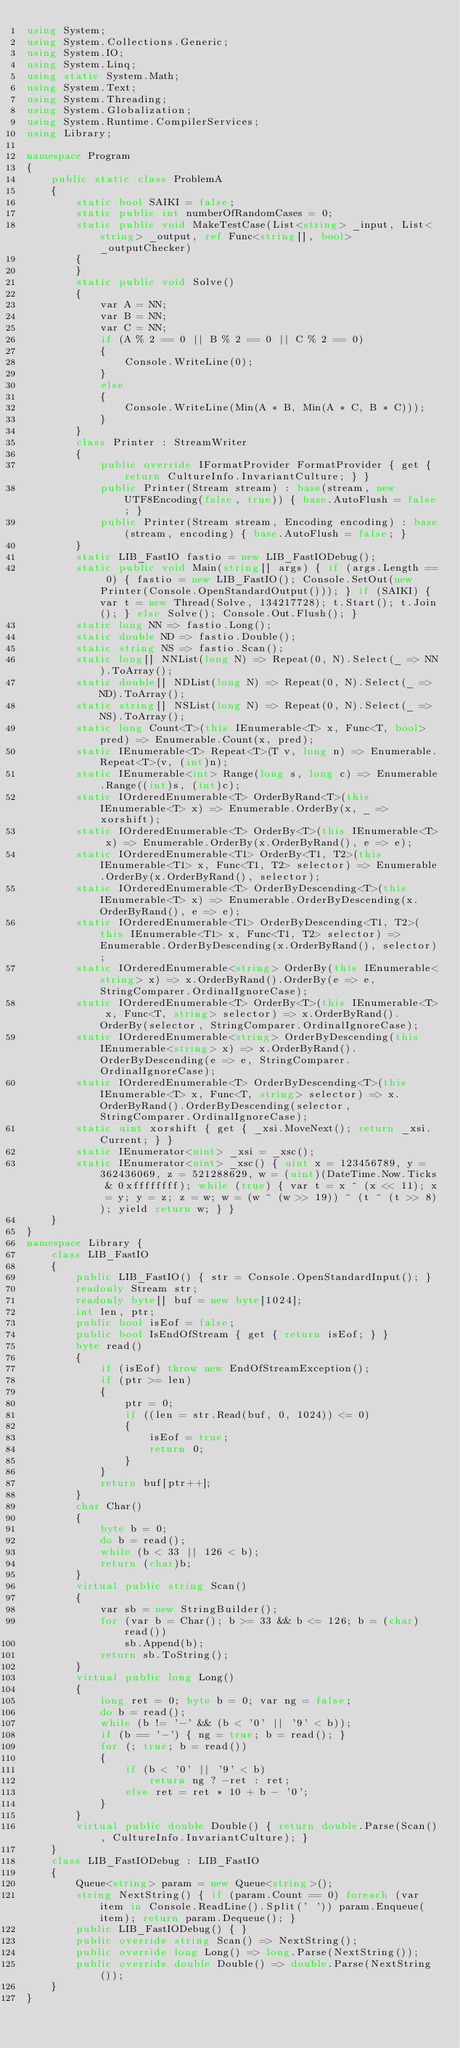<code> <loc_0><loc_0><loc_500><loc_500><_C#_>using System;
using System.Collections.Generic;
using System.IO;
using System.Linq;
using static System.Math;
using System.Text;
using System.Threading;
using System.Globalization;
using System.Runtime.CompilerServices;
using Library;

namespace Program
{
    public static class ProblemA
    {
        static bool SAIKI = false;
        static public int numberOfRandomCases = 0;
        static public void MakeTestCase(List<string> _input, List<string> _output, ref Func<string[], bool> _outputChecker)
        {
        }
        static public void Solve()
        {
            var A = NN;
            var B = NN;
            var C = NN;
            if (A % 2 == 0 || B % 2 == 0 || C % 2 == 0)
            {
                Console.WriteLine(0);
            }
            else
            {
                Console.WriteLine(Min(A * B, Min(A * C, B * C)));
            }
        }
        class Printer : StreamWriter
        {
            public override IFormatProvider FormatProvider { get { return CultureInfo.InvariantCulture; } }
            public Printer(Stream stream) : base(stream, new UTF8Encoding(false, true)) { base.AutoFlush = false; }
            public Printer(Stream stream, Encoding encoding) : base(stream, encoding) { base.AutoFlush = false; }
        }
        static LIB_FastIO fastio = new LIB_FastIODebug();
        static public void Main(string[] args) { if (args.Length == 0) { fastio = new LIB_FastIO(); Console.SetOut(new Printer(Console.OpenStandardOutput())); } if (SAIKI) { var t = new Thread(Solve, 134217728); t.Start(); t.Join(); } else Solve(); Console.Out.Flush(); }
        static long NN => fastio.Long();
        static double ND => fastio.Double();
        static string NS => fastio.Scan();
        static long[] NNList(long N) => Repeat(0, N).Select(_ => NN).ToArray();
        static double[] NDList(long N) => Repeat(0, N).Select(_ => ND).ToArray();
        static string[] NSList(long N) => Repeat(0, N).Select(_ => NS).ToArray();
        static long Count<T>(this IEnumerable<T> x, Func<T, bool> pred) => Enumerable.Count(x, pred);
        static IEnumerable<T> Repeat<T>(T v, long n) => Enumerable.Repeat<T>(v, (int)n);
        static IEnumerable<int> Range(long s, long c) => Enumerable.Range((int)s, (int)c);
        static IOrderedEnumerable<T> OrderByRand<T>(this IEnumerable<T> x) => Enumerable.OrderBy(x, _ => xorshift);
        static IOrderedEnumerable<T> OrderBy<T>(this IEnumerable<T> x) => Enumerable.OrderBy(x.OrderByRand(), e => e);
        static IOrderedEnumerable<T1> OrderBy<T1, T2>(this IEnumerable<T1> x, Func<T1, T2> selector) => Enumerable.OrderBy(x.OrderByRand(), selector);
        static IOrderedEnumerable<T> OrderByDescending<T>(this IEnumerable<T> x) => Enumerable.OrderByDescending(x.OrderByRand(), e => e);
        static IOrderedEnumerable<T1> OrderByDescending<T1, T2>(this IEnumerable<T1> x, Func<T1, T2> selector) => Enumerable.OrderByDescending(x.OrderByRand(), selector);
        static IOrderedEnumerable<string> OrderBy(this IEnumerable<string> x) => x.OrderByRand().OrderBy(e => e, StringComparer.OrdinalIgnoreCase);
        static IOrderedEnumerable<T> OrderBy<T>(this IEnumerable<T> x, Func<T, string> selector) => x.OrderByRand().OrderBy(selector, StringComparer.OrdinalIgnoreCase);
        static IOrderedEnumerable<string> OrderByDescending(this IEnumerable<string> x) => x.OrderByRand().OrderByDescending(e => e, StringComparer.OrdinalIgnoreCase);
        static IOrderedEnumerable<T> OrderByDescending<T>(this IEnumerable<T> x, Func<T, string> selector) => x.OrderByRand().OrderByDescending(selector, StringComparer.OrdinalIgnoreCase);
        static uint xorshift { get { _xsi.MoveNext(); return _xsi.Current; } }
        static IEnumerator<uint> _xsi = _xsc();
        static IEnumerator<uint> _xsc() { uint x = 123456789, y = 362436069, z = 521288629, w = (uint)(DateTime.Now.Ticks & 0xffffffff); while (true) { var t = x ^ (x << 11); x = y; y = z; z = w; w = (w ^ (w >> 19)) ^ (t ^ (t >> 8)); yield return w; } }
    }
}
namespace Library {
    class LIB_FastIO
    {
        public LIB_FastIO() { str = Console.OpenStandardInput(); }
        readonly Stream str;
        readonly byte[] buf = new byte[1024];
        int len, ptr;
        public bool isEof = false;
        public bool IsEndOfStream { get { return isEof; } }
        byte read()
        {
            if (isEof) throw new EndOfStreamException();
            if (ptr >= len)
            {
                ptr = 0;
                if ((len = str.Read(buf, 0, 1024)) <= 0)
                {
                    isEof = true;
                    return 0;
                }
            }
            return buf[ptr++];
        }
        char Char()
        {
            byte b = 0;
            do b = read();
            while (b < 33 || 126 < b);
            return (char)b;
        }
        virtual public string Scan()
        {
            var sb = new StringBuilder();
            for (var b = Char(); b >= 33 && b <= 126; b = (char)read())
                sb.Append(b);
            return sb.ToString();
        }
        virtual public long Long()
        {
            long ret = 0; byte b = 0; var ng = false;
            do b = read();
            while (b != '-' && (b < '0' || '9' < b));
            if (b == '-') { ng = true; b = read(); }
            for (; true; b = read())
            {
                if (b < '0' || '9' < b)
                    return ng ? -ret : ret;
                else ret = ret * 10 + b - '0';
            }
        }
        virtual public double Double() { return double.Parse(Scan(), CultureInfo.InvariantCulture); }
    }
    class LIB_FastIODebug : LIB_FastIO
    {
        Queue<string> param = new Queue<string>();
        string NextString() { if (param.Count == 0) foreach (var item in Console.ReadLine().Split(' ')) param.Enqueue(item); return param.Dequeue(); }
        public LIB_FastIODebug() { }
        public override string Scan() => NextString();
        public override long Long() => long.Parse(NextString());
        public override double Double() => double.Parse(NextString());
    }
}
</code> 